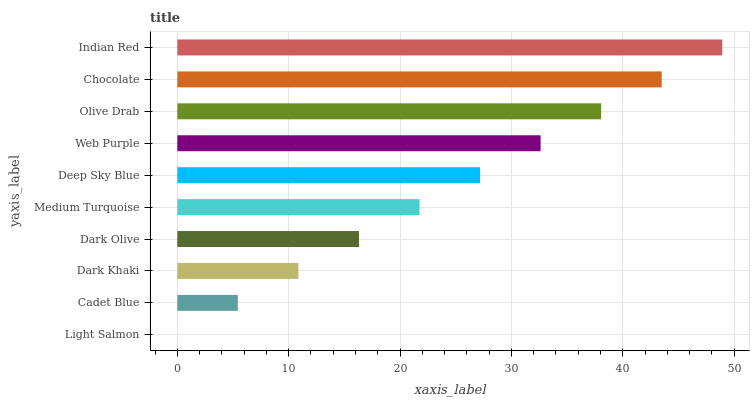Is Light Salmon the minimum?
Answer yes or no. Yes. Is Indian Red the maximum?
Answer yes or no. Yes. Is Cadet Blue the minimum?
Answer yes or no. No. Is Cadet Blue the maximum?
Answer yes or no. No. Is Cadet Blue greater than Light Salmon?
Answer yes or no. Yes. Is Light Salmon less than Cadet Blue?
Answer yes or no. Yes. Is Light Salmon greater than Cadet Blue?
Answer yes or no. No. Is Cadet Blue less than Light Salmon?
Answer yes or no. No. Is Deep Sky Blue the high median?
Answer yes or no. Yes. Is Medium Turquoise the low median?
Answer yes or no. Yes. Is Web Purple the high median?
Answer yes or no. No. Is Dark Olive the low median?
Answer yes or no. No. 